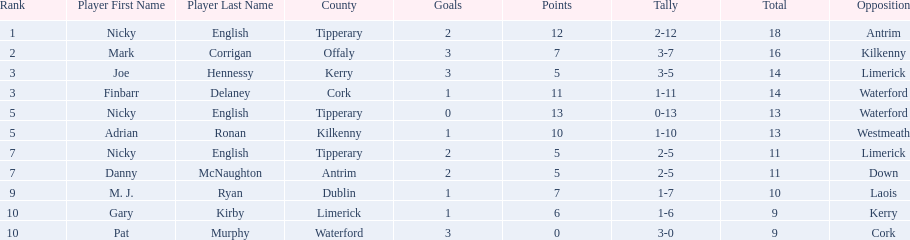What is the least total on the list? 9. Could you help me parse every detail presented in this table? {'header': ['Rank', 'Player First Name', 'Player Last Name', 'County', 'Goals', 'Points', 'Tally', 'Total', 'Opposition'], 'rows': [['1', 'Nicky', 'English', 'Tipperary', '2', '12', '2-12', '18', 'Antrim'], ['2', 'Mark', 'Corrigan', 'Offaly', '3', '7', '3-7', '16', 'Kilkenny'], ['3', 'Joe', 'Hennessy', 'Kerry', '3', '5', '3-5', '14', 'Limerick'], ['3', 'Finbarr', 'Delaney', 'Cork', '1', '11', '1-11', '14', 'Waterford'], ['5', 'Nicky', 'English', 'Tipperary', '0', '13', '0-13', '13', 'Waterford'], ['5', 'Adrian', 'Ronan', 'Kilkenny', '1', '10', '1-10', '13', 'Westmeath'], ['7', 'Nicky', 'English', 'Tipperary', '2', '5', '2-5', '11', 'Limerick'], ['7', 'Danny', 'McNaughton', 'Antrim', '2', '5', '2-5', '11', 'Down'], ['9', 'M. J.', 'Ryan', 'Dublin', '1', '7', '1-7', '10', 'Laois'], ['10', 'Gary', 'Kirby', 'Limerick', '1', '6', '1-6', '9', 'Kerry'], ['10', 'Pat', 'Murphy', 'Waterford', '3', '0', '3-0', '9', 'Cork']]} 